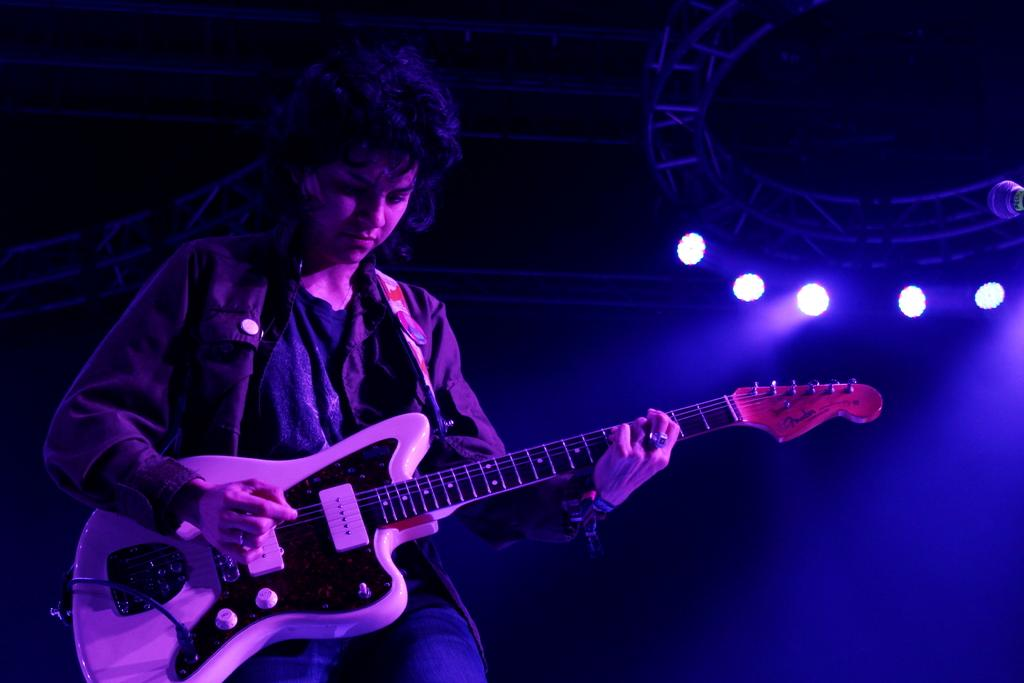Who is the main subject in the image? There is a woman in the image. What is the woman doing in the image? The woman is standing and playing the guitar. What type of clothing is the woman wearing? The woman is wearing a coat-type shirt. What additional feature can be seen on the right side of the image? Disco lights are visible on the right side of the image. How many birds are sitting on the woman's shoulder in the image? There are no birds present in the image. What is the price of the guitar the woman is playing in the image? The price of the guitar cannot be determined from the image. 